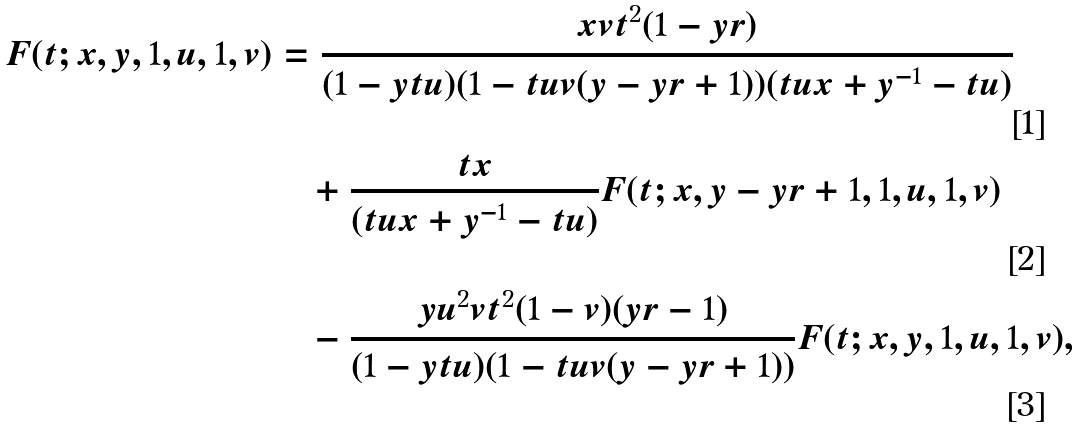<formula> <loc_0><loc_0><loc_500><loc_500>F ( t ; x , y , 1 , u , 1 , v ) & = \frac { x v t ^ { 2 } ( 1 - y r ) } { ( 1 - y t u ) ( 1 - t u v ( y - y r + 1 ) ) ( t u x + y ^ { - 1 } - t u ) } \\ & \quad + \frac { t x } { ( t u x + y ^ { - 1 } - t u ) } F ( t ; x , y - y r + 1 , 1 , u , 1 , v ) \\ & \quad - \frac { y u ^ { 2 } v t ^ { 2 } ( 1 - v ) ( y r - 1 ) } { ( 1 - y t u ) ( 1 - t u v ( y - y r + 1 ) ) } F ( t ; x , y , 1 , u , 1 , v ) ,</formula> 